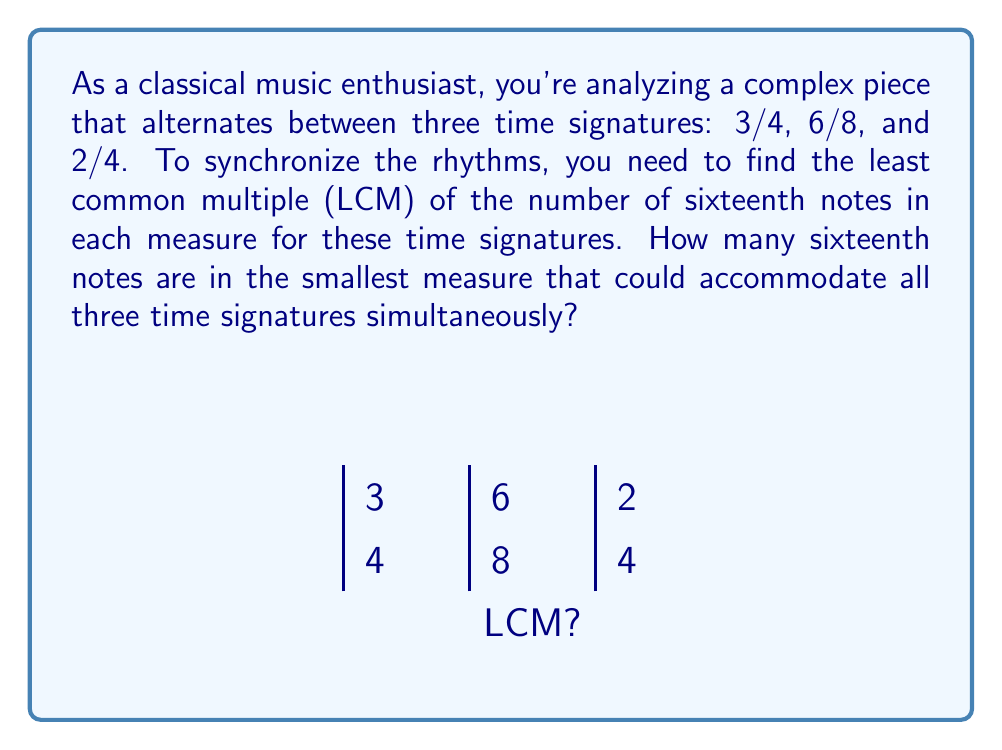Can you solve this math problem? Let's approach this step-by-step:

1) First, we need to calculate how many sixteenth notes are in each measure for each time signature:

   - 3/4 time: $3 \times 4 = 12$ sixteenth notes
   - 6/8 time: $6 \times 2 = 12$ sixteenth notes
   - 2/4 time: $2 \times 4 = 8$ sixteenth notes

2) Now, we need to find the LCM of 12 and 8.

3) To find the LCM, let's first find the prime factorization of each number:
   
   $12 = 2^2 \times 3$
   $8 = 2^3$

4) The LCM will include the highest power of each prime factor:

   $LCM(12, 8) = 2^3 \times 3 = 24$

5) Therefore, the smallest measure that could accommodate all three time signatures simultaneously would contain 24 sixteenth notes.

This means that:
- It would be equivalent to 2 measures of 3/4 time
- It would be equivalent to 2 measures of 6/8 time
- It would be equivalent to 3 measures of 2/4 time
Answer: 24 sixteenth notes 